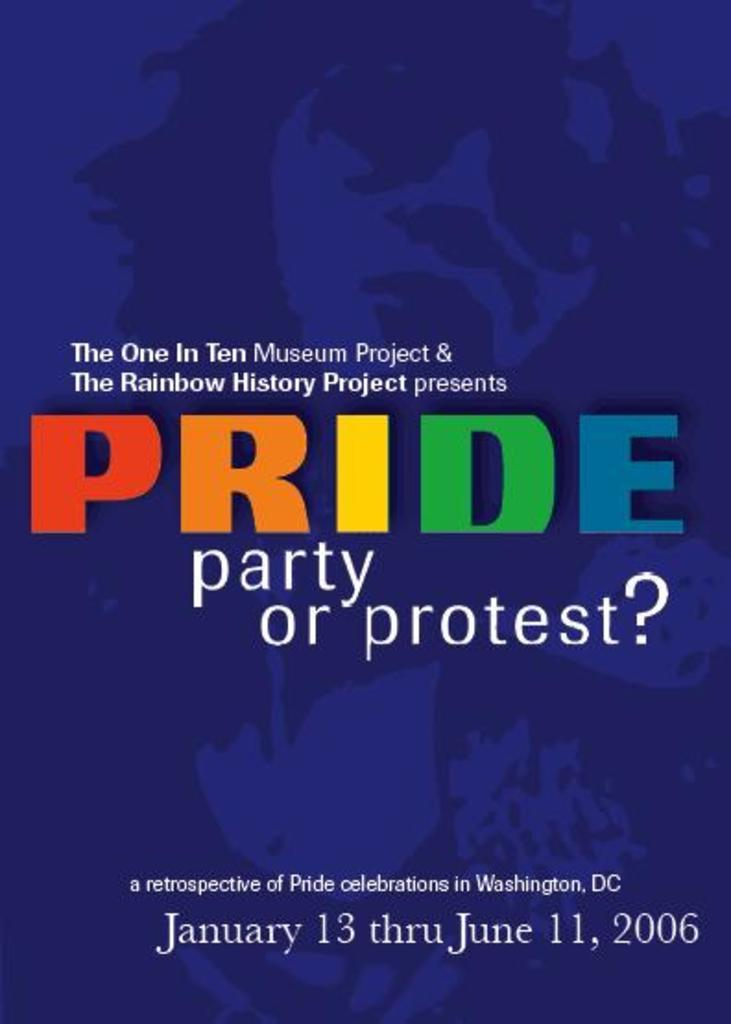<image>
Share a concise interpretation of the image provided. The museum is having an exhibit about Pride interests. 